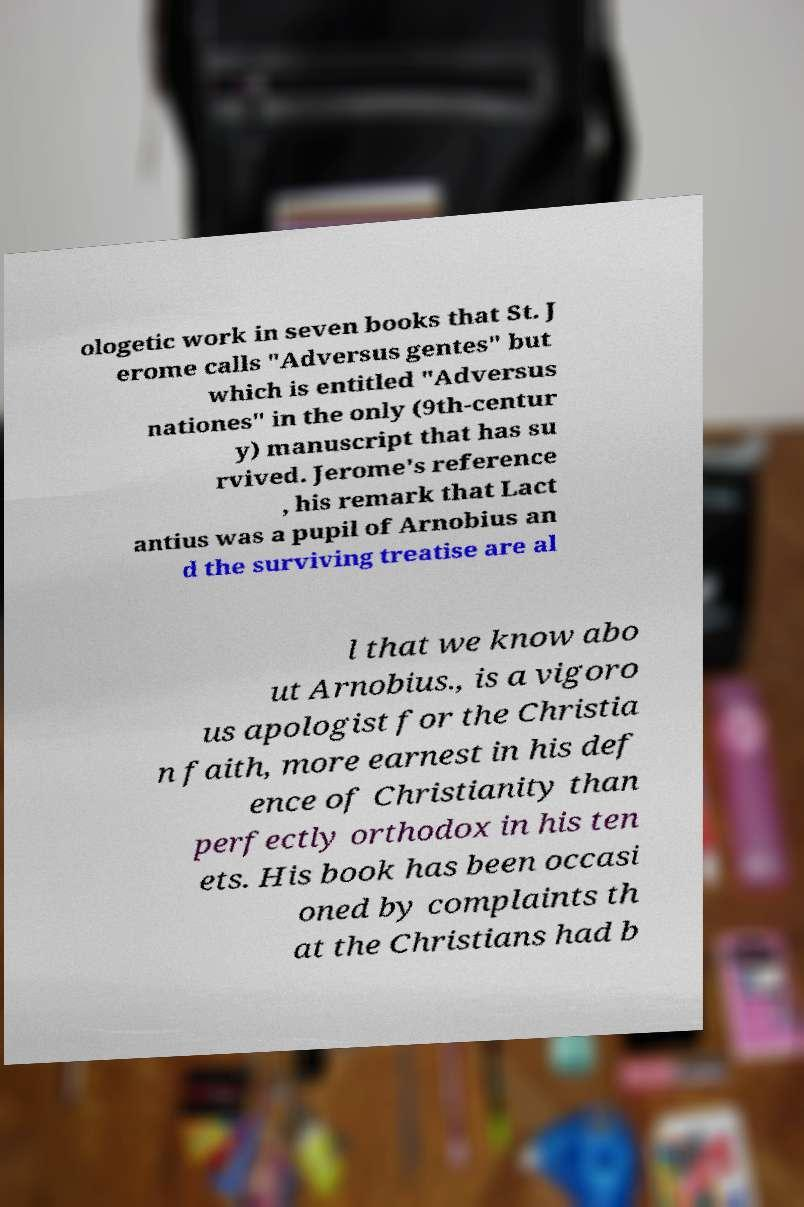I need the written content from this picture converted into text. Can you do that? ologetic work in seven books that St. J erome calls "Adversus gentes" but which is entitled "Adversus nationes" in the only (9th-centur y) manuscript that has su rvived. Jerome's reference , his remark that Lact antius was a pupil of Arnobius an d the surviving treatise are al l that we know abo ut Arnobius., is a vigoro us apologist for the Christia n faith, more earnest in his def ence of Christianity than perfectly orthodox in his ten ets. His book has been occasi oned by complaints th at the Christians had b 